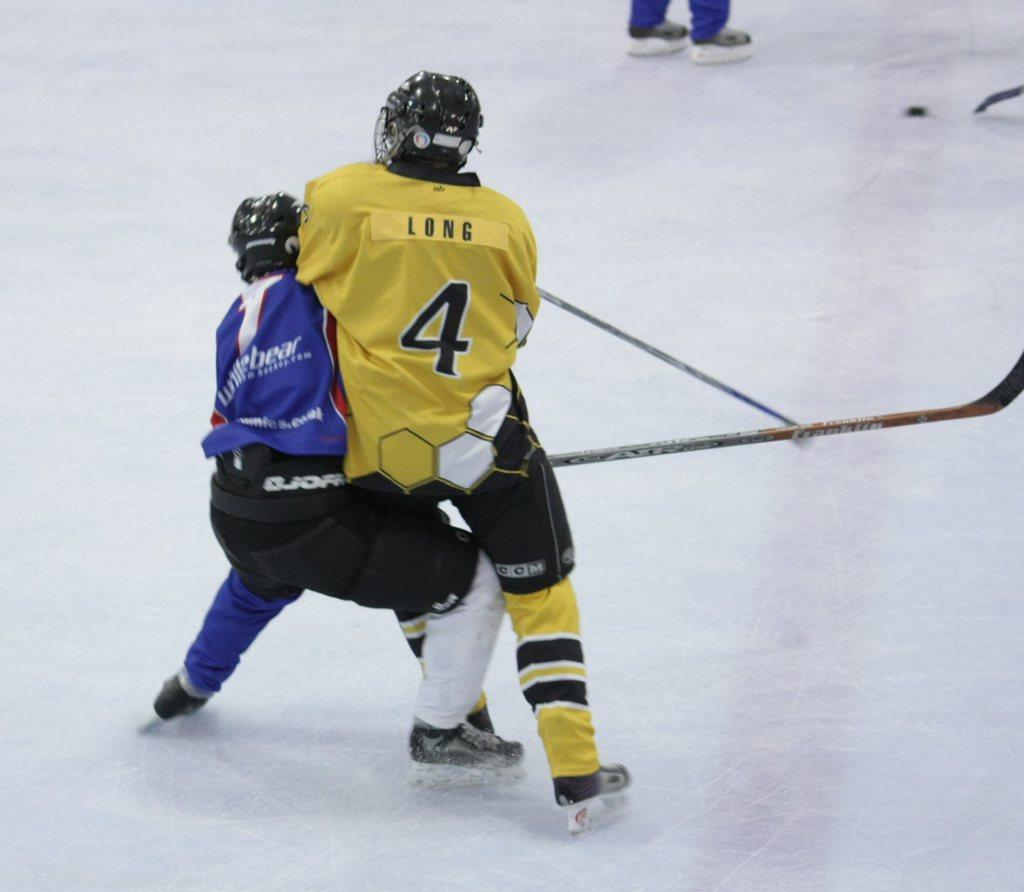How many people are in the image? There are people in the image, but the exact number is not specified. What type of footwear are the people wearing? The people are wearing skate shoes. What protective gear are the people wearing? The people are wearing helmets. What objects are the people holding? The people are holding sticks. What is the color of the land in the image? The land in the image is white. Whose legs are visible at the top of the image? The legs visible at the top of the image belong to a person. What type of cloud can be seen in the image? There is no cloud visible in the image; the land is white. What is the purpose of the feather in the image? There is no feather present in the image. 